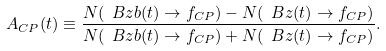<formula> <loc_0><loc_0><loc_500><loc_500>A _ { C P } ( t ) \equiv \frac { N ( \ B z b ( t ) \to f _ { C P } ) - N ( \ B z ( t ) \to f _ { C P } ) } { N ( \ B z b ( t ) \to f _ { C P } ) + N ( \ B z ( t ) \to f _ { C P } ) } .</formula> 